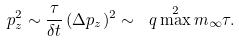<formula> <loc_0><loc_0><loc_500><loc_500>p _ { z } ^ { 2 } \sim \frac { \tau } { \delta t } \, ( \Delta p _ { z } ) ^ { 2 } \sim \ q \max ^ { 2 } m _ { \infty } \tau .</formula> 